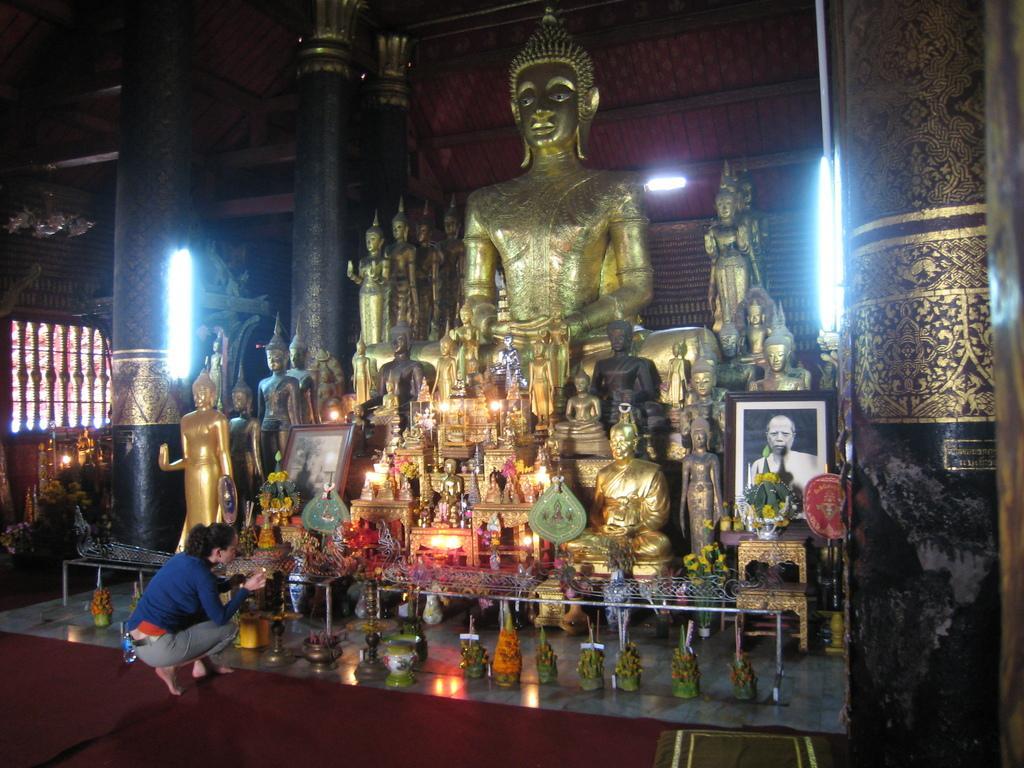Could you give a brief overview of what you see in this image? In this picture, I can see few statues and a photo frame on the right side and a flower vase on the table and i can see a human and few lights. 